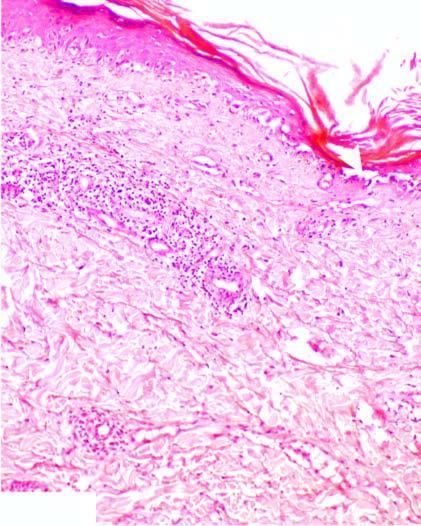does intact show hydropic degeneration and loss of dermoepidermal junction?
Answer the question using a single word or phrase. No 